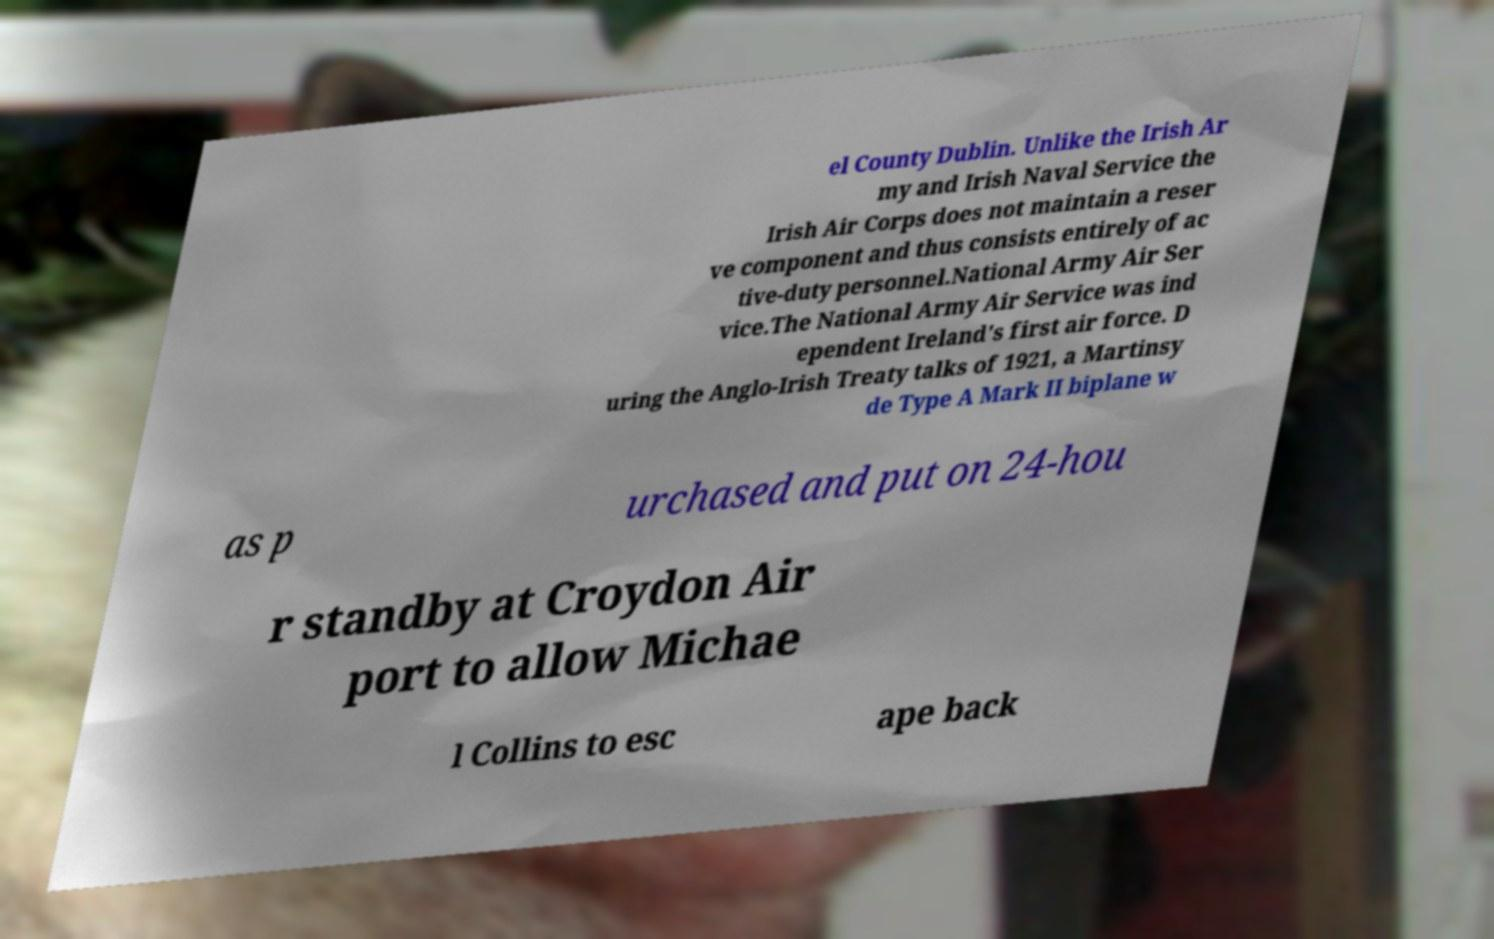Can you read and provide the text displayed in the image?This photo seems to have some interesting text. Can you extract and type it out for me? el County Dublin. Unlike the Irish Ar my and Irish Naval Service the Irish Air Corps does not maintain a reser ve component and thus consists entirely of ac tive-duty personnel.National Army Air Ser vice.The National Army Air Service was ind ependent Ireland's first air force. D uring the Anglo-Irish Treaty talks of 1921, a Martinsy de Type A Mark II biplane w as p urchased and put on 24-hou r standby at Croydon Air port to allow Michae l Collins to esc ape back 